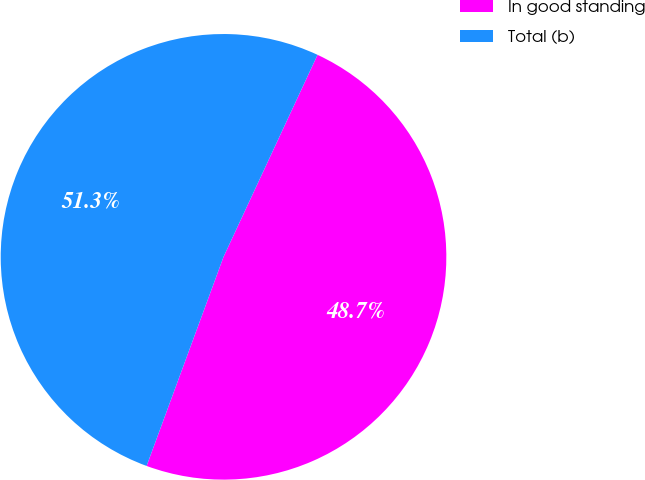Convert chart. <chart><loc_0><loc_0><loc_500><loc_500><pie_chart><fcel>In good standing<fcel>Total (b)<nl><fcel>48.68%<fcel>51.32%<nl></chart> 